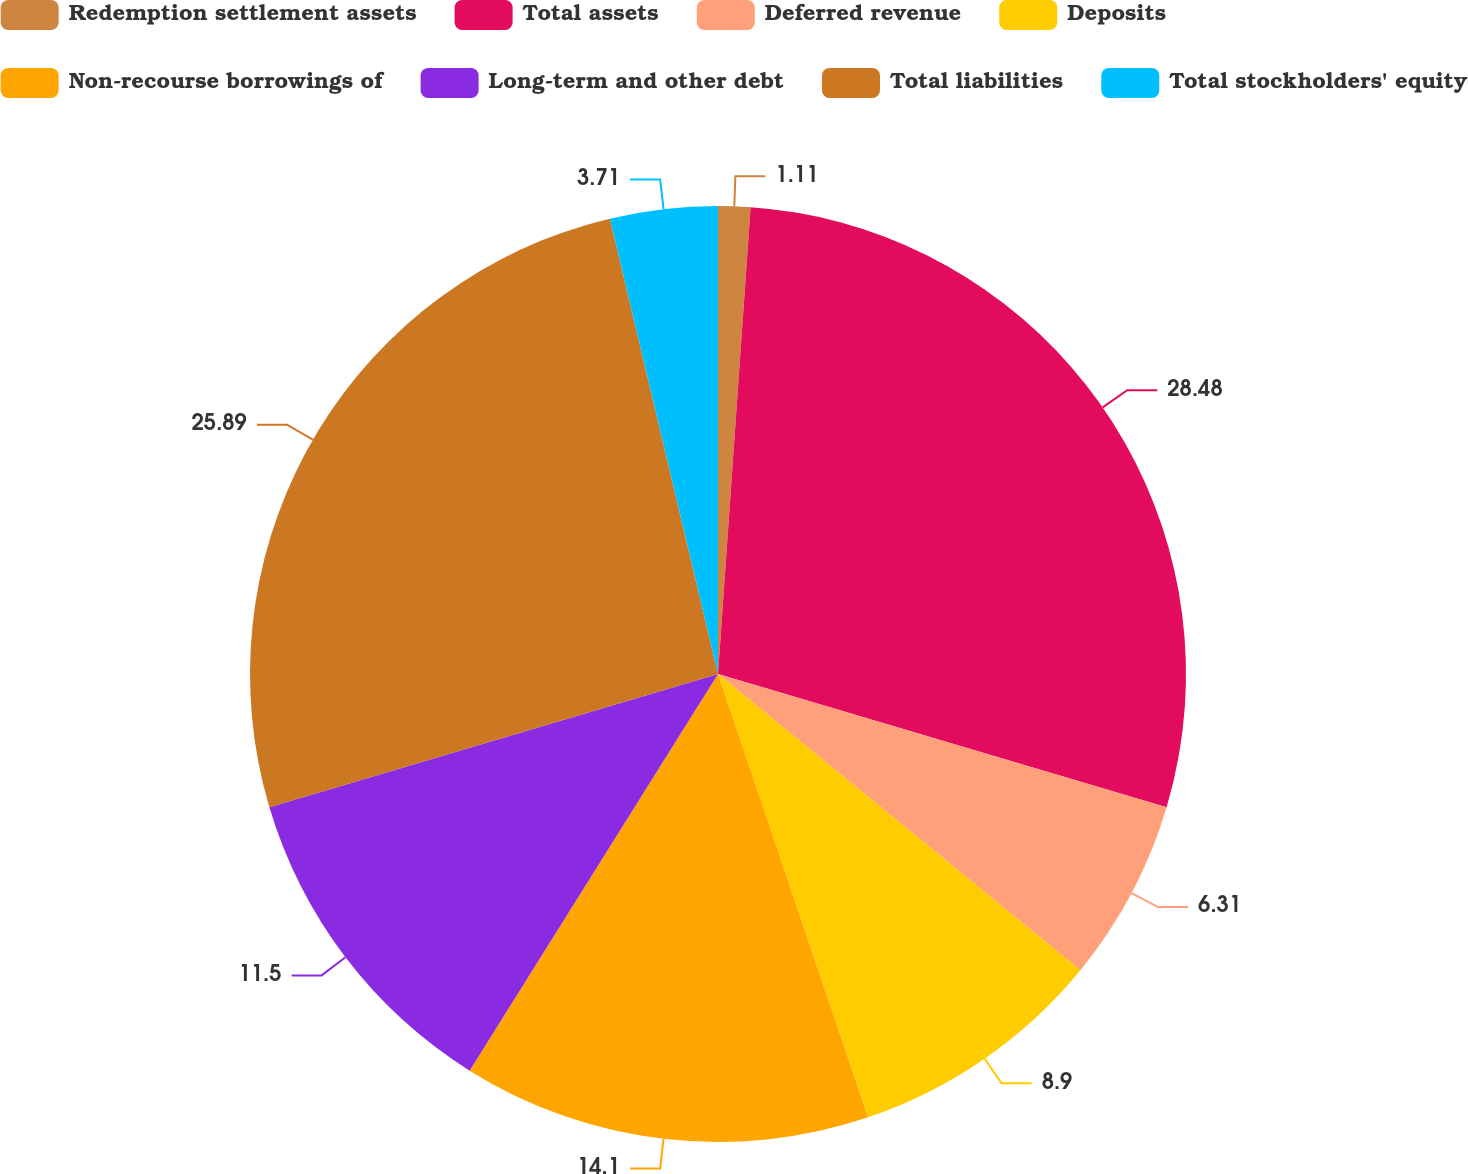Convert chart to OTSL. <chart><loc_0><loc_0><loc_500><loc_500><pie_chart><fcel>Redemption settlement assets<fcel>Total assets<fcel>Deferred revenue<fcel>Deposits<fcel>Non-recourse borrowings of<fcel>Long-term and other debt<fcel>Total liabilities<fcel>Total stockholders' equity<nl><fcel>1.11%<fcel>28.49%<fcel>6.31%<fcel>8.9%<fcel>14.1%<fcel>11.5%<fcel>25.89%<fcel>3.71%<nl></chart> 